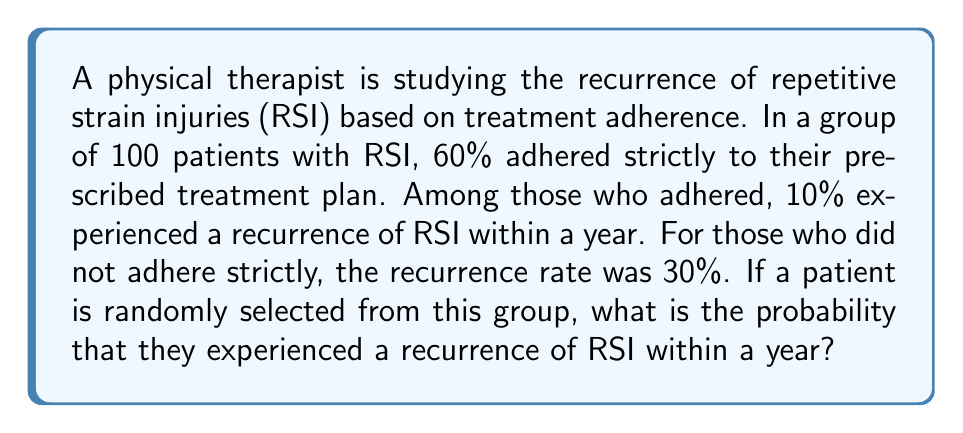Solve this math problem. Let's approach this step-by-step using the law of total probability:

1) Define events:
   A: Patient adhered to treatment
   R: Patient experienced recurrence

2) Given probabilities:
   $P(A) = 0.60$ (60% adhered)
   $P(R|A) = 0.10$ (10% recurrence rate for adherent patients)
   $P(R|\overline{A}) = 0.30$ (30% recurrence rate for non-adherent patients)

3) Law of Total Probability:
   $P(R) = P(R|A) \cdot P(A) + P(R|\overline{A}) \cdot P(\overline{A})$

4) Calculate $P(\overline{A})$:
   $P(\overline{A}) = 1 - P(A) = 1 - 0.60 = 0.40$

5) Substitute values into the formula:
   $P(R) = 0.10 \cdot 0.60 + 0.30 \cdot 0.40$

6) Calculate:
   $P(R) = 0.06 + 0.12 = 0.18$

Therefore, the probability that a randomly selected patient experienced a recurrence of RSI within a year is 0.18 or 18%.
Answer: 0.18 